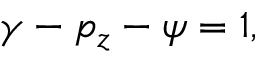Convert formula to latex. <formula><loc_0><loc_0><loc_500><loc_500>\begin{array} { r } { \gamma - p _ { z } - \psi = 1 , } \end{array}</formula> 